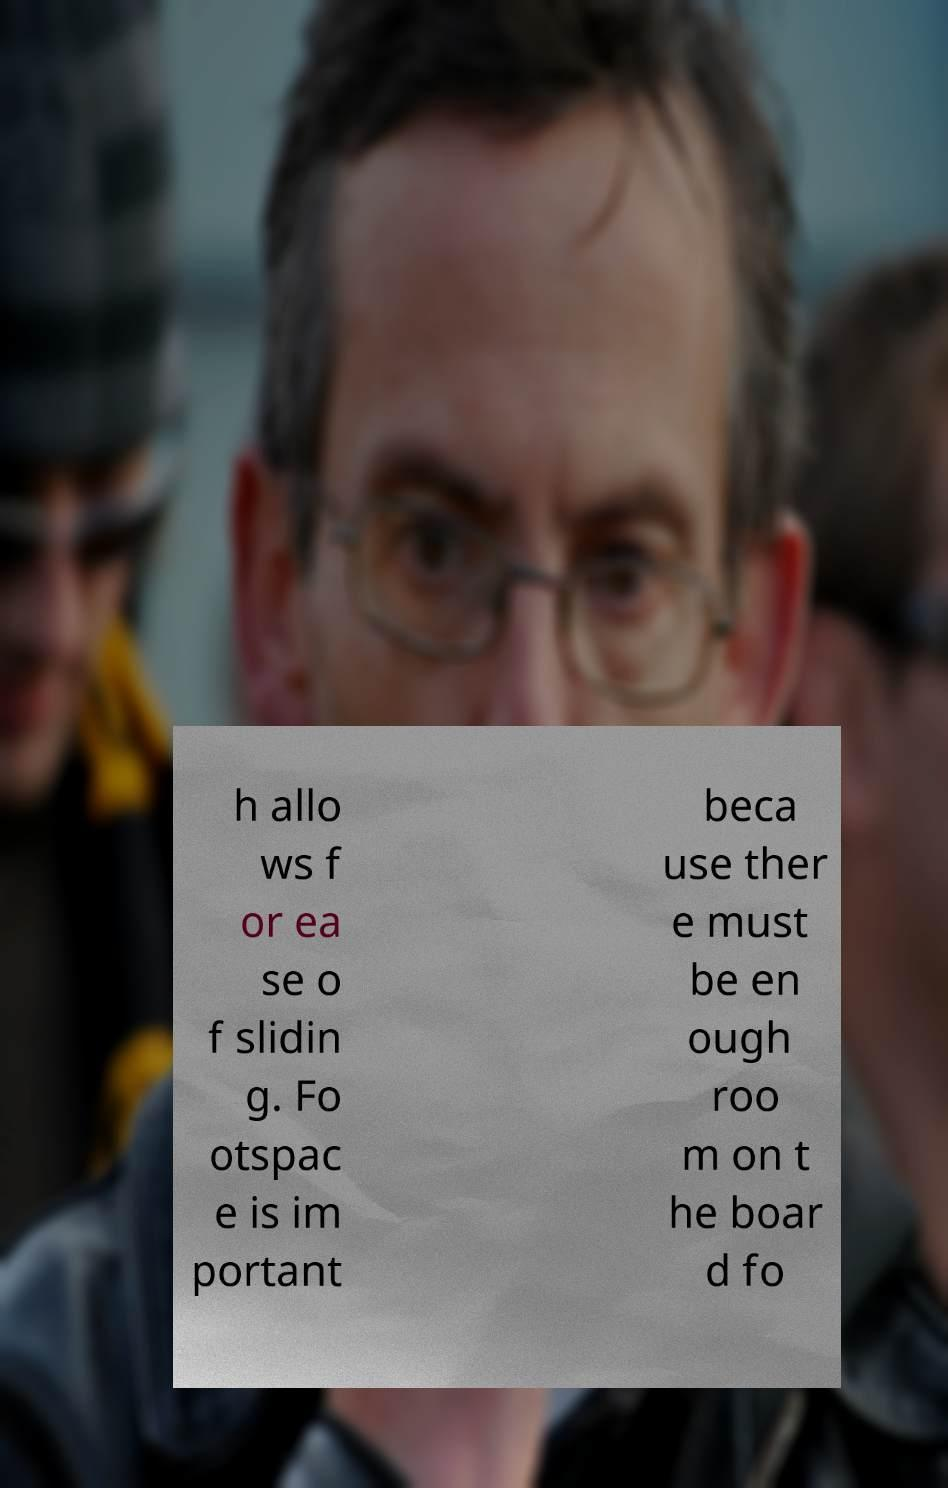Could you extract and type out the text from this image? h allo ws f or ea se o f slidin g. Fo otspac e is im portant beca use ther e must be en ough roo m on t he boar d fo 